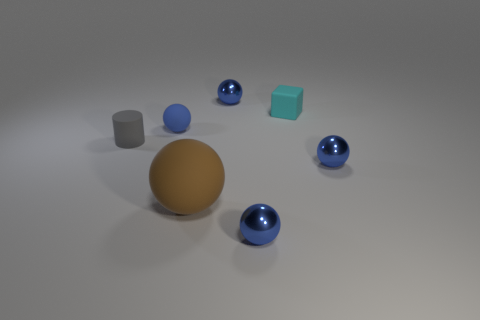Is there anything else that is the same size as the brown sphere?
Your answer should be very brief. No. Are there any tiny blue matte things that have the same shape as the brown rubber object?
Make the answer very short. Yes. What number of other things are the same shape as the large rubber thing?
Provide a succinct answer. 4. There is a big brown rubber object; is its shape the same as the small metal object behind the tiny gray cylinder?
Make the answer very short. Yes. What number of tiny things are either gray rubber cubes or brown spheres?
Your answer should be compact. 0. Is the number of rubber cylinders that are to the right of the tiny blue rubber object less than the number of small metallic things that are behind the tiny gray matte object?
Ensure brevity in your answer.  Yes. How many things are blue rubber spheres or blue metal balls?
Your answer should be very brief. 4. There is a tiny matte block; what number of blue objects are on the right side of it?
Ensure brevity in your answer.  1. Do the small matte block and the large thing have the same color?
Keep it short and to the point. No. There is a gray thing that is the same material as the cyan thing; what shape is it?
Offer a very short reply. Cylinder. 